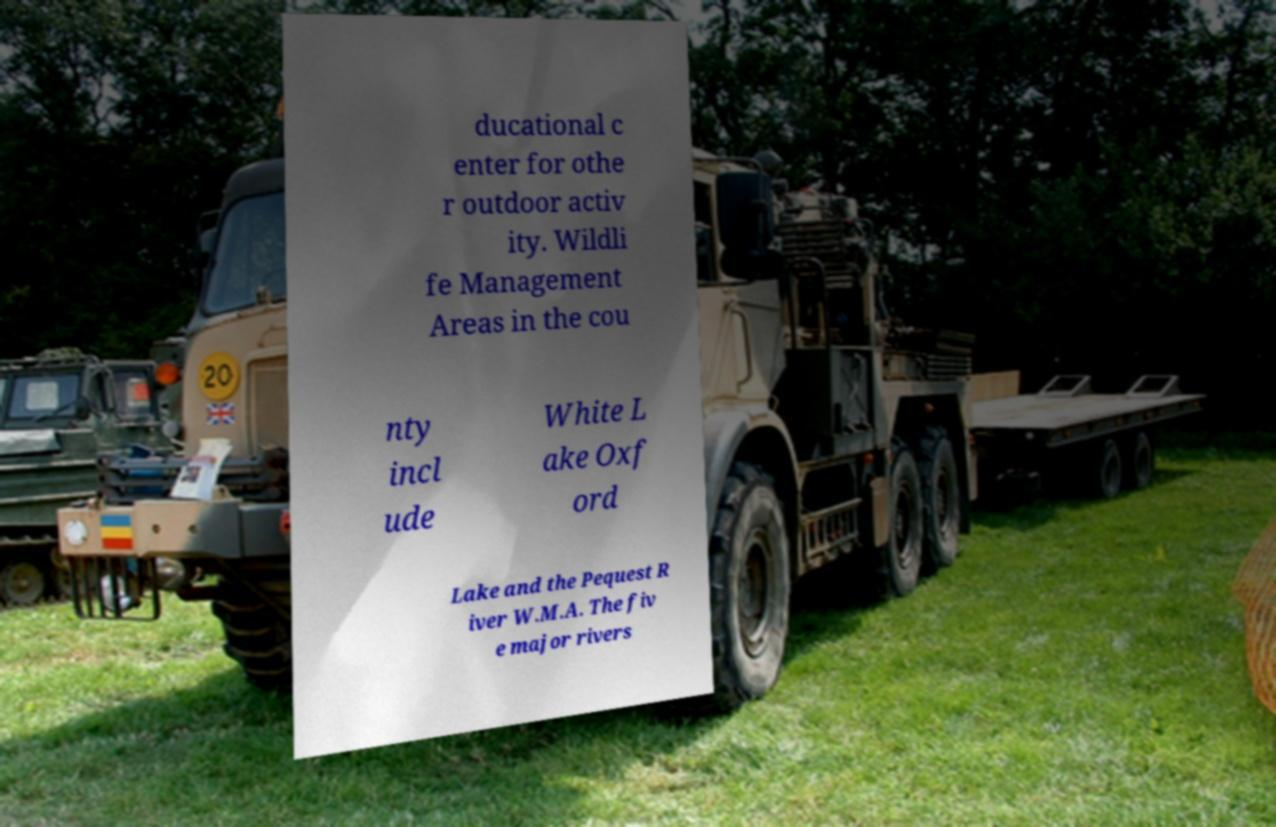Could you extract and type out the text from this image? ducational c enter for othe r outdoor activ ity. Wildli fe Management Areas in the cou nty incl ude White L ake Oxf ord Lake and the Pequest R iver W.M.A. The fiv e major rivers 